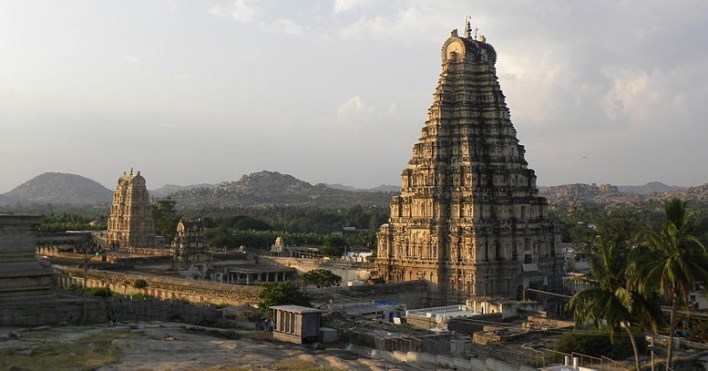Can you describe the historical significance of the temple in the image? The Virupaksha Temple is part of the Group of Monuments at Hampi, designated as a UNESCO World Heritage Site. Hampi was once the capital of the Vijayanagara Empire, and this temple is one of the longstanding structures that survived the empire's fall in the 16th century. Throughout history, it has remained an important pilgrimage site, and it's one of the few active temples in Hampi, continuously engaging in religious practices for centuries. 